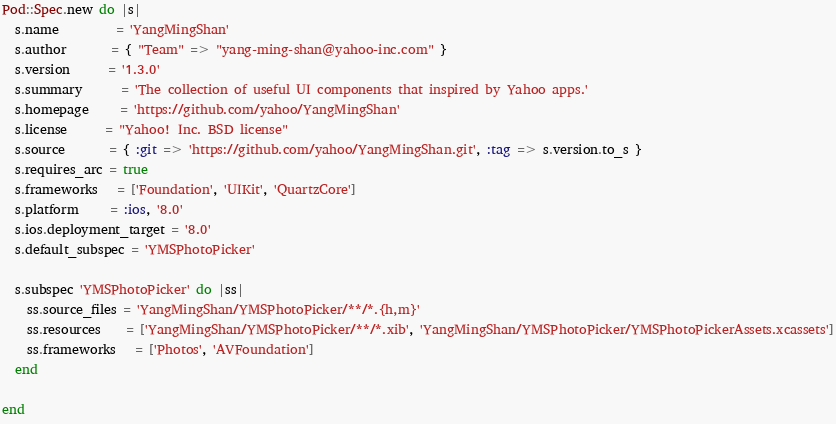Convert code to text. <code><loc_0><loc_0><loc_500><loc_500><_Ruby_>Pod::Spec.new do |s|
  s.name         = 'YangMingShan'
  s.author       = { "Team" => "yang-ming-shan@yahoo-inc.com" }
  s.version      = '1.3.0'
  s.summary      = 'The collection of useful UI components that inspired by Yahoo apps.'
  s.homepage     = 'https://github.com/yahoo/YangMingShan'
  s.license      = "Yahoo! Inc. BSD license"
  s.source       = { :git => 'https://github.com/yahoo/YangMingShan.git', :tag => s.version.to_s }
  s.requires_arc = true
  s.frameworks   = ['Foundation', 'UIKit', 'QuartzCore']
  s.platform     = :ios, '8.0'
  s.ios.deployment_target = '8.0'
  s.default_subspec = 'YMSPhotoPicker'

  s.subspec 'YMSPhotoPicker' do |ss|
    ss.source_files = 'YangMingShan/YMSPhotoPicker/**/*.{h,m}'
    ss.resources    = ['YangMingShan/YMSPhotoPicker/**/*.xib', 'YangMingShan/YMSPhotoPicker/YMSPhotoPickerAssets.xcassets']
    ss.frameworks   = ['Photos', 'AVFoundation']
  end

end
</code> 